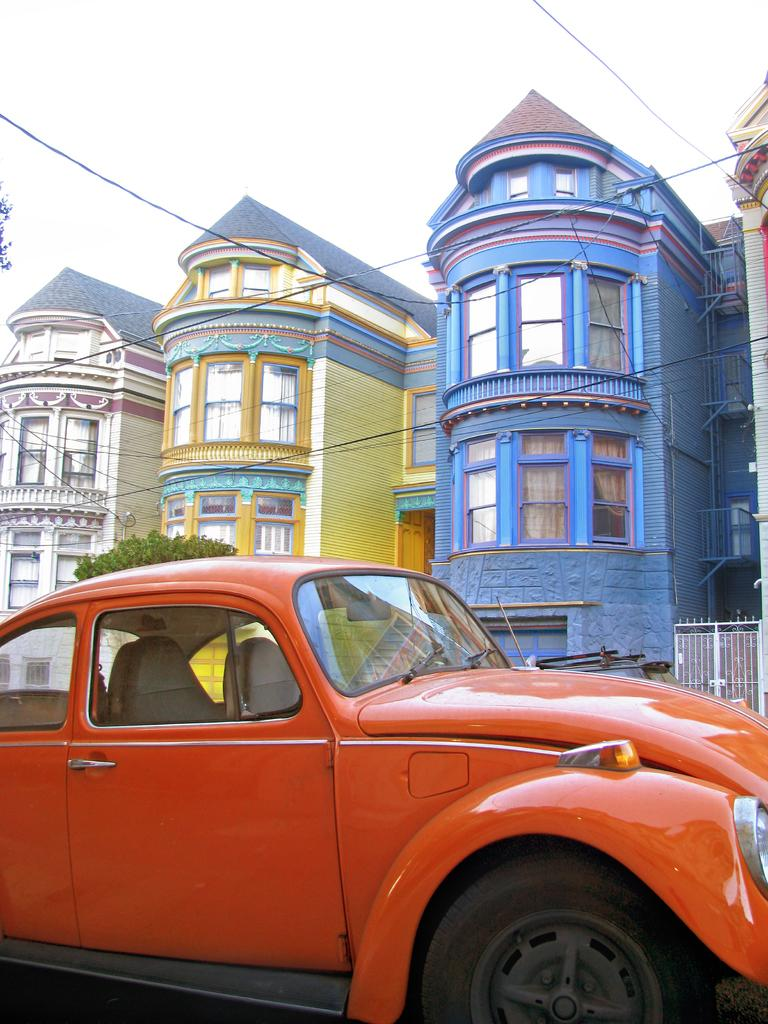What type of car is in the foreground of the image? There is an orange car in the foreground of the image. What can be seen in the background of the image? There is a white gate, buildings, a tree, cables, and the sky visible in the background of the image. How many different structures can be seen in the background of the image? There are at least three different structures visible in the background: a white gate, buildings, and a tree. What advertisement is being displayed on the nerve of the person in the image? There is no person or nerve present in the image, and therefore no advertisement can be observed. 